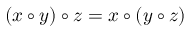Convert formula to latex. <formula><loc_0><loc_0><loc_500><loc_500>( x \circ y ) \circ z = x \circ ( y \circ z )</formula> 